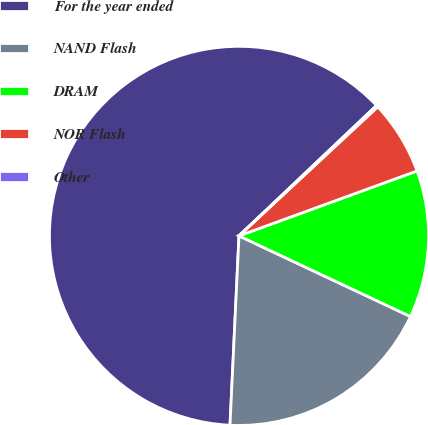<chart> <loc_0><loc_0><loc_500><loc_500><pie_chart><fcel>For the year ended<fcel>NAND Flash<fcel>DRAM<fcel>NOR Flash<fcel>Other<nl><fcel>62.17%<fcel>18.76%<fcel>12.56%<fcel>6.36%<fcel>0.15%<nl></chart> 